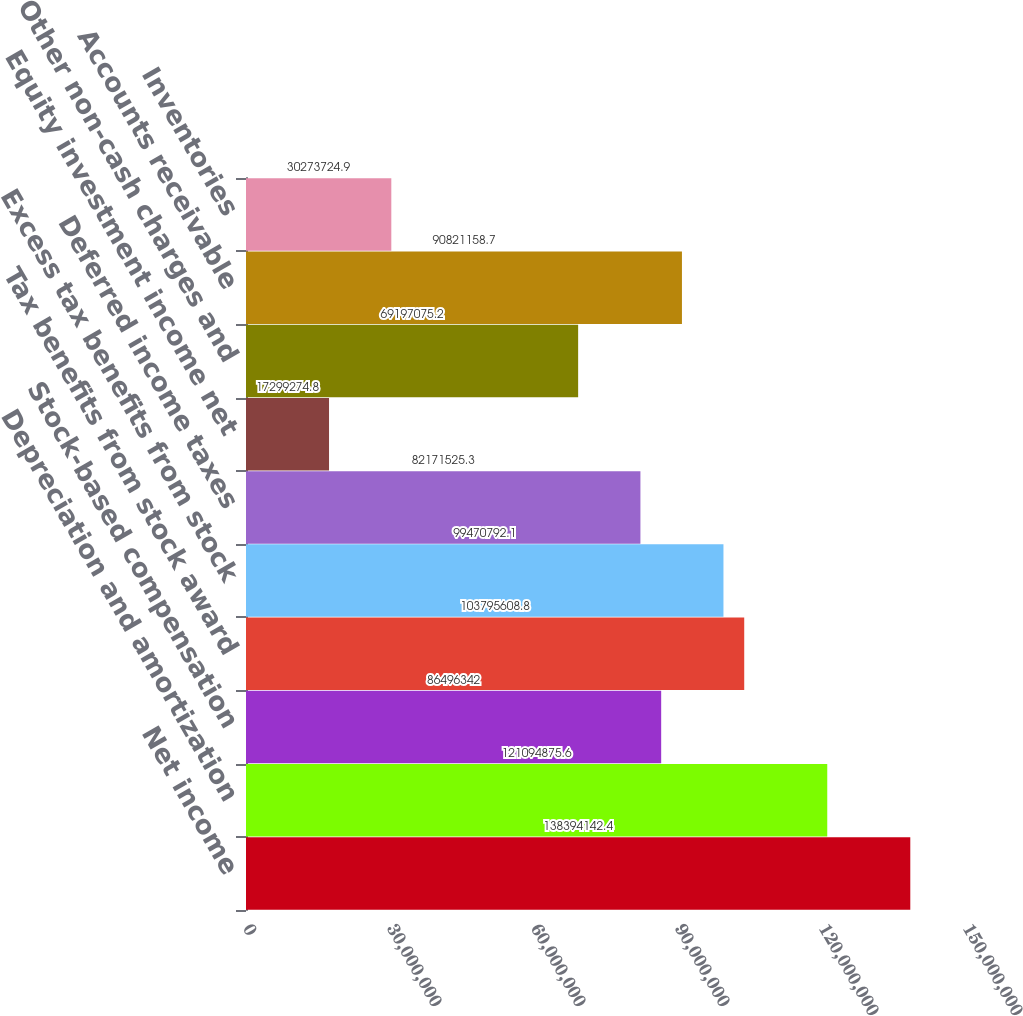<chart> <loc_0><loc_0><loc_500><loc_500><bar_chart><fcel>Net income<fcel>Depreciation and amortization<fcel>Stock-based compensation<fcel>Tax benefits from stock award<fcel>Excess tax benefits from stock<fcel>Deferred income taxes<fcel>Equity investment income net<fcel>Other non-cash charges and<fcel>Accounts receivable<fcel>Inventories<nl><fcel>1.38394e+08<fcel>1.21095e+08<fcel>8.64963e+07<fcel>1.03796e+08<fcel>9.94708e+07<fcel>8.21715e+07<fcel>1.72993e+07<fcel>6.91971e+07<fcel>9.08212e+07<fcel>3.02737e+07<nl></chart> 